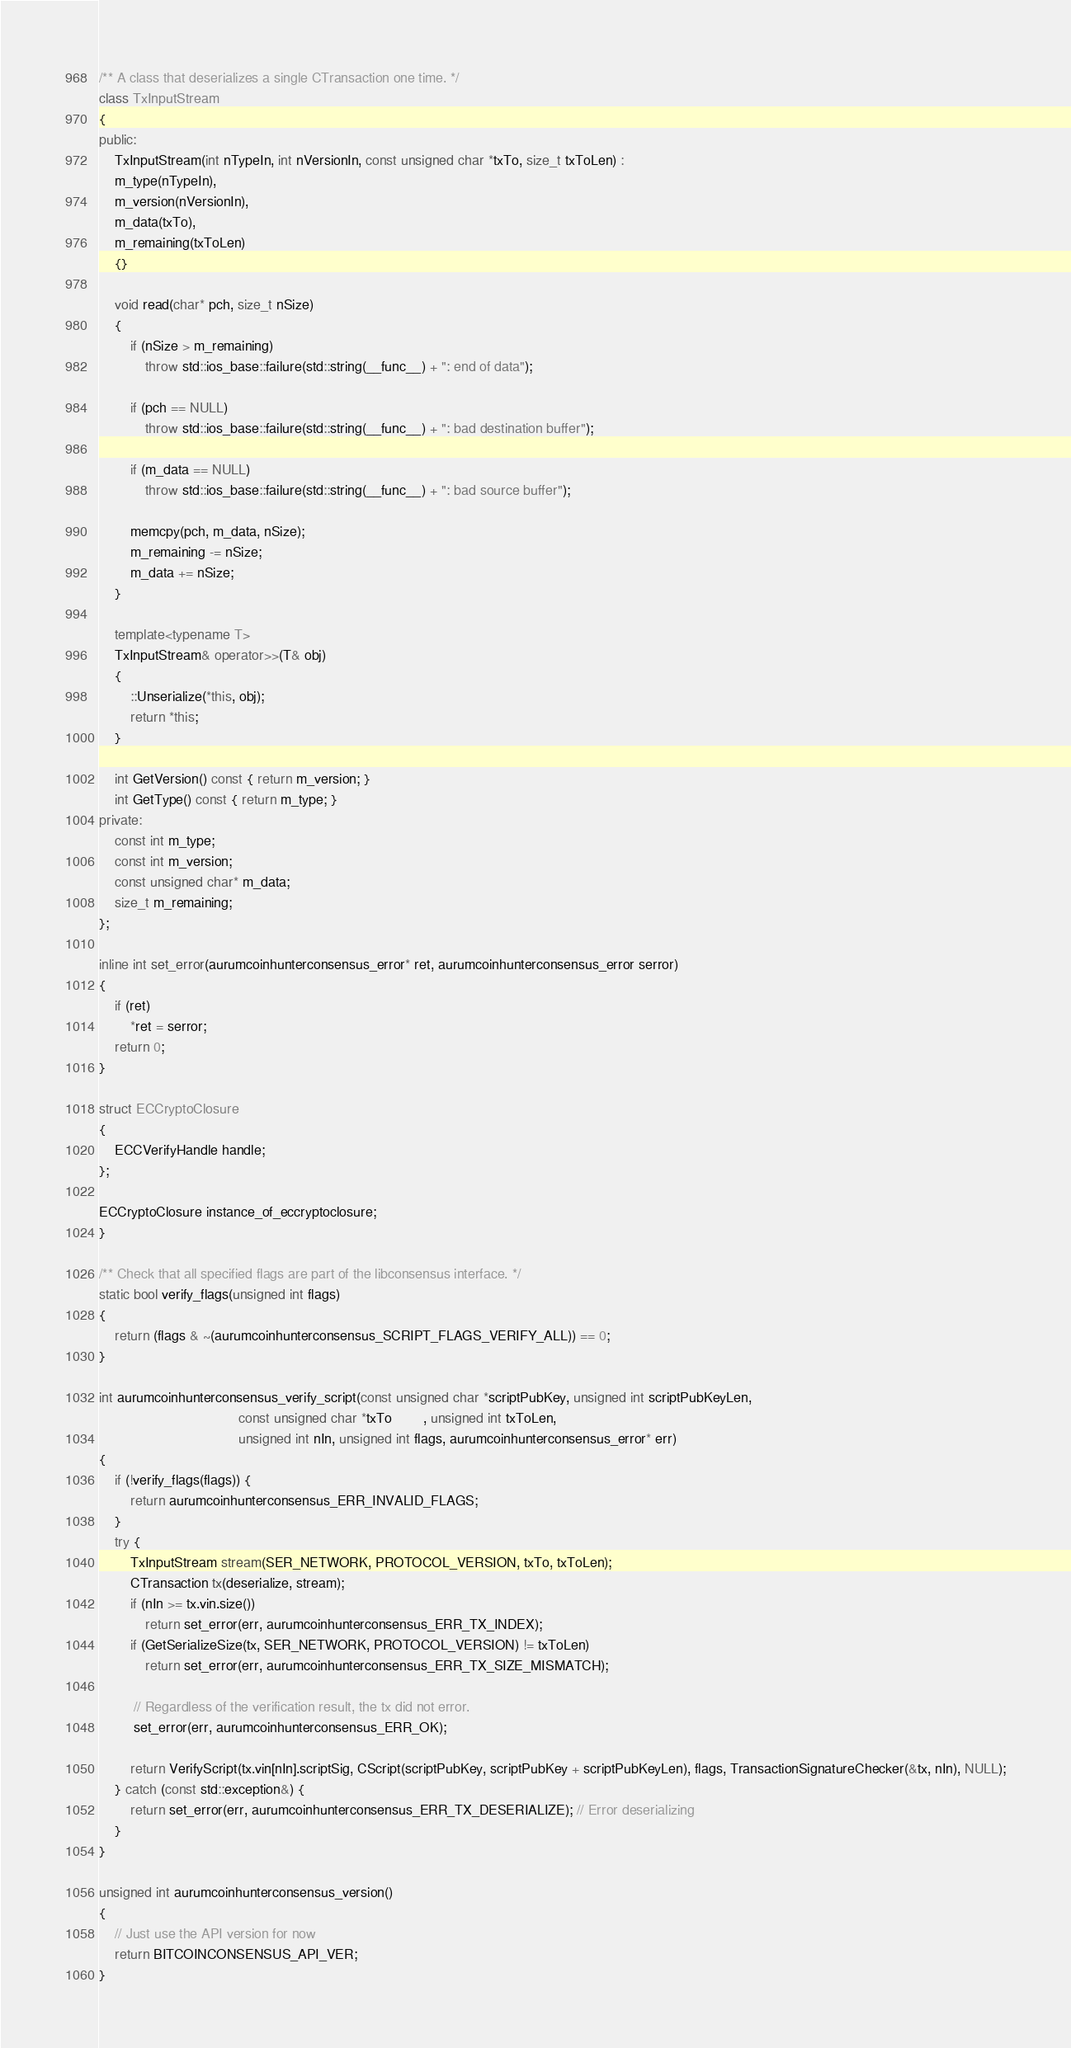Convert code to text. <code><loc_0><loc_0><loc_500><loc_500><_C++_>/** A class that deserializes a single CTransaction one time. */
class TxInputStream
{
public:
    TxInputStream(int nTypeIn, int nVersionIn, const unsigned char *txTo, size_t txToLen) :
    m_type(nTypeIn),
    m_version(nVersionIn),
    m_data(txTo),
    m_remaining(txToLen)
    {}

    void read(char* pch, size_t nSize)
    {
        if (nSize > m_remaining)
            throw std::ios_base::failure(std::string(__func__) + ": end of data");

        if (pch == NULL)
            throw std::ios_base::failure(std::string(__func__) + ": bad destination buffer");

        if (m_data == NULL)
            throw std::ios_base::failure(std::string(__func__) + ": bad source buffer");

        memcpy(pch, m_data, nSize);
        m_remaining -= nSize;
        m_data += nSize;
    }

    template<typename T>
    TxInputStream& operator>>(T& obj)
    {
        ::Unserialize(*this, obj);
        return *this;
    }

    int GetVersion() const { return m_version; }
    int GetType() const { return m_type; }
private:
    const int m_type;
    const int m_version;
    const unsigned char* m_data;
    size_t m_remaining;
};

inline int set_error(aurumcoinhunterconsensus_error* ret, aurumcoinhunterconsensus_error serror)
{
    if (ret)
        *ret = serror;
    return 0;
}

struct ECCryptoClosure
{
    ECCVerifyHandle handle;
};

ECCryptoClosure instance_of_eccryptoclosure;
}

/** Check that all specified flags are part of the libconsensus interface. */
static bool verify_flags(unsigned int flags)
{
    return (flags & ~(aurumcoinhunterconsensus_SCRIPT_FLAGS_VERIFY_ALL)) == 0;
}

int aurumcoinhunterconsensus_verify_script(const unsigned char *scriptPubKey, unsigned int scriptPubKeyLen,
                                    const unsigned char *txTo        , unsigned int txToLen,
                                    unsigned int nIn, unsigned int flags, aurumcoinhunterconsensus_error* err)
{
    if (!verify_flags(flags)) {
        return aurumcoinhunterconsensus_ERR_INVALID_FLAGS;
    }
    try {
        TxInputStream stream(SER_NETWORK, PROTOCOL_VERSION, txTo, txToLen);
        CTransaction tx(deserialize, stream);
        if (nIn >= tx.vin.size())
            return set_error(err, aurumcoinhunterconsensus_ERR_TX_INDEX);
        if (GetSerializeSize(tx, SER_NETWORK, PROTOCOL_VERSION) != txToLen)
            return set_error(err, aurumcoinhunterconsensus_ERR_TX_SIZE_MISMATCH);

         // Regardless of the verification result, the tx did not error.
         set_error(err, aurumcoinhunterconsensus_ERR_OK);

        return VerifyScript(tx.vin[nIn].scriptSig, CScript(scriptPubKey, scriptPubKey + scriptPubKeyLen), flags, TransactionSignatureChecker(&tx, nIn), NULL);
    } catch (const std::exception&) {
        return set_error(err, aurumcoinhunterconsensus_ERR_TX_DESERIALIZE); // Error deserializing
    }
}

unsigned int aurumcoinhunterconsensus_version()
{
    // Just use the API version for now
    return BITCOINCONSENSUS_API_VER;
}
</code> 